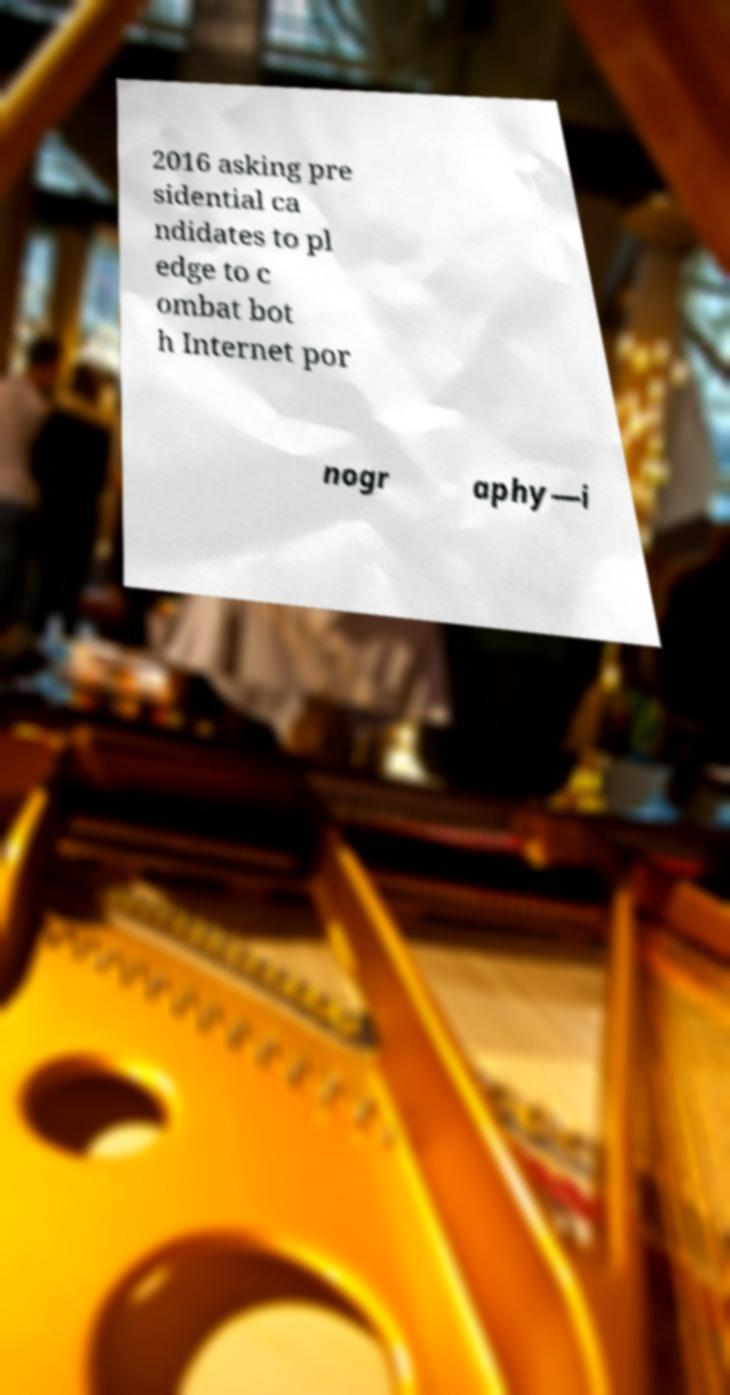Could you extract and type out the text from this image? 2016 asking pre sidential ca ndidates to pl edge to c ombat bot h Internet por nogr aphy—i 